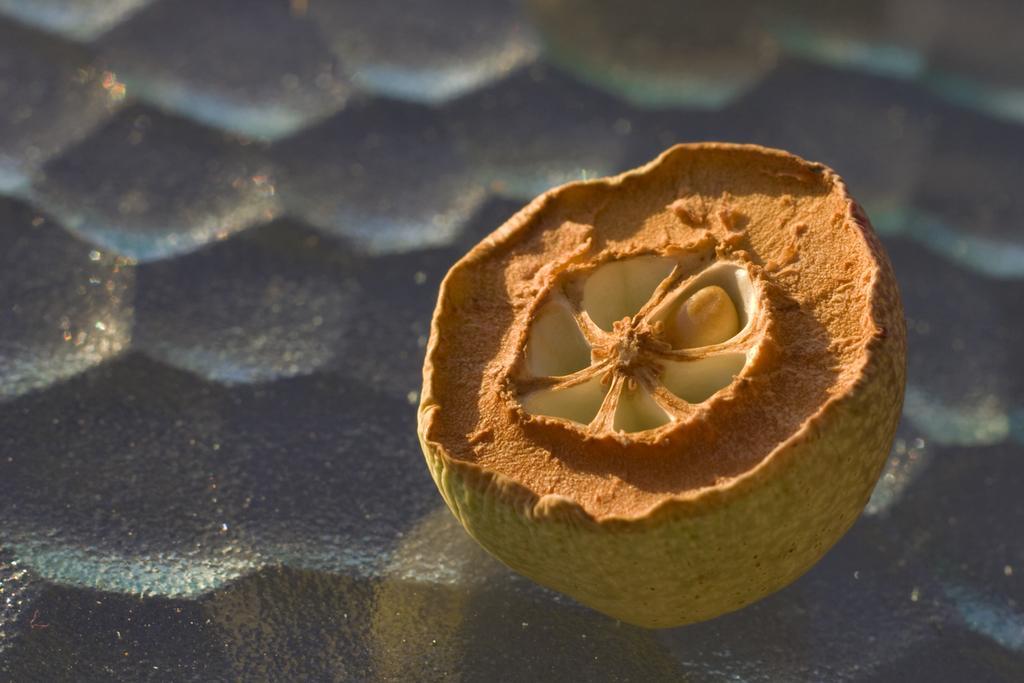Please provide a concise description of this image. In this picture I can see the fruit which is kept on the ground. 